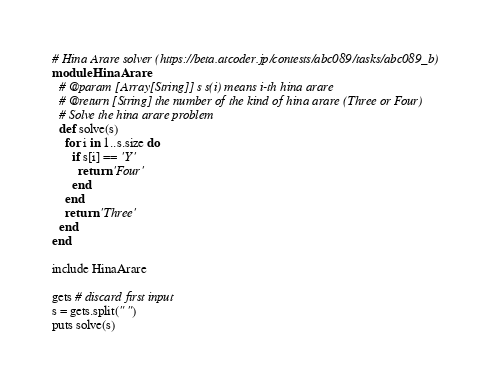Convert code to text. <code><loc_0><loc_0><loc_500><loc_500><_Ruby_># Hina Arare solver (https://beta.atcoder.jp/contests/abc089/tasks/abc089_b)
module HinaArare
  # @param [Array[String]] s s(i) means i-th hina arare
  # @return [String] the number of the kind of hina arare (Three or Four)
  # Solve the hina arare problem
  def solve(s)
    for i in 1..s.size do
      if s[i] == 'Y'
        return 'Four'
      end
    end
    return 'Three'
  end
end

include HinaArare

gets # discard first input
s = gets.split(" ")
puts solve(s)</code> 